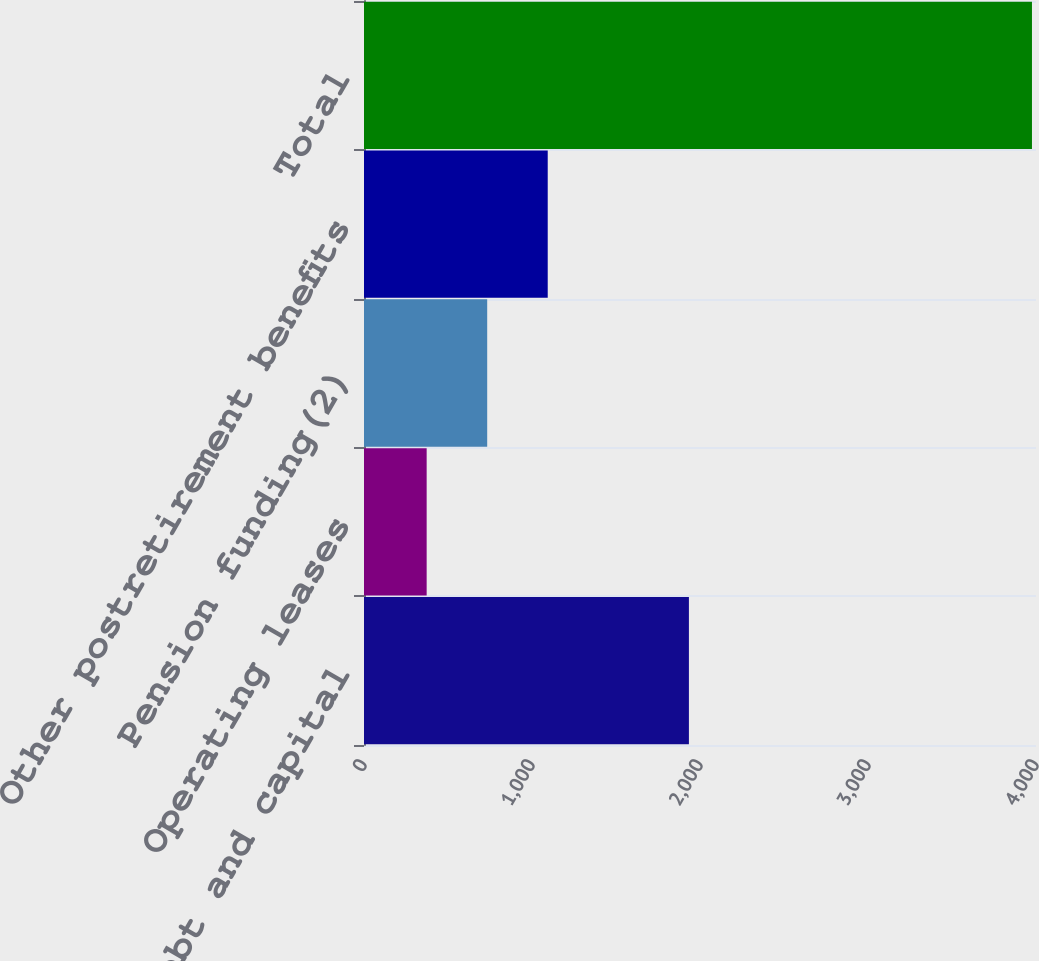<chart> <loc_0><loc_0><loc_500><loc_500><bar_chart><fcel>Long-term debt and capital<fcel>Operating leases<fcel>Pension funding(2)<fcel>Other postretirement benefits<fcel>Total<nl><fcel>1934<fcel>373<fcel>733.3<fcel>1093.6<fcel>3976<nl></chart> 